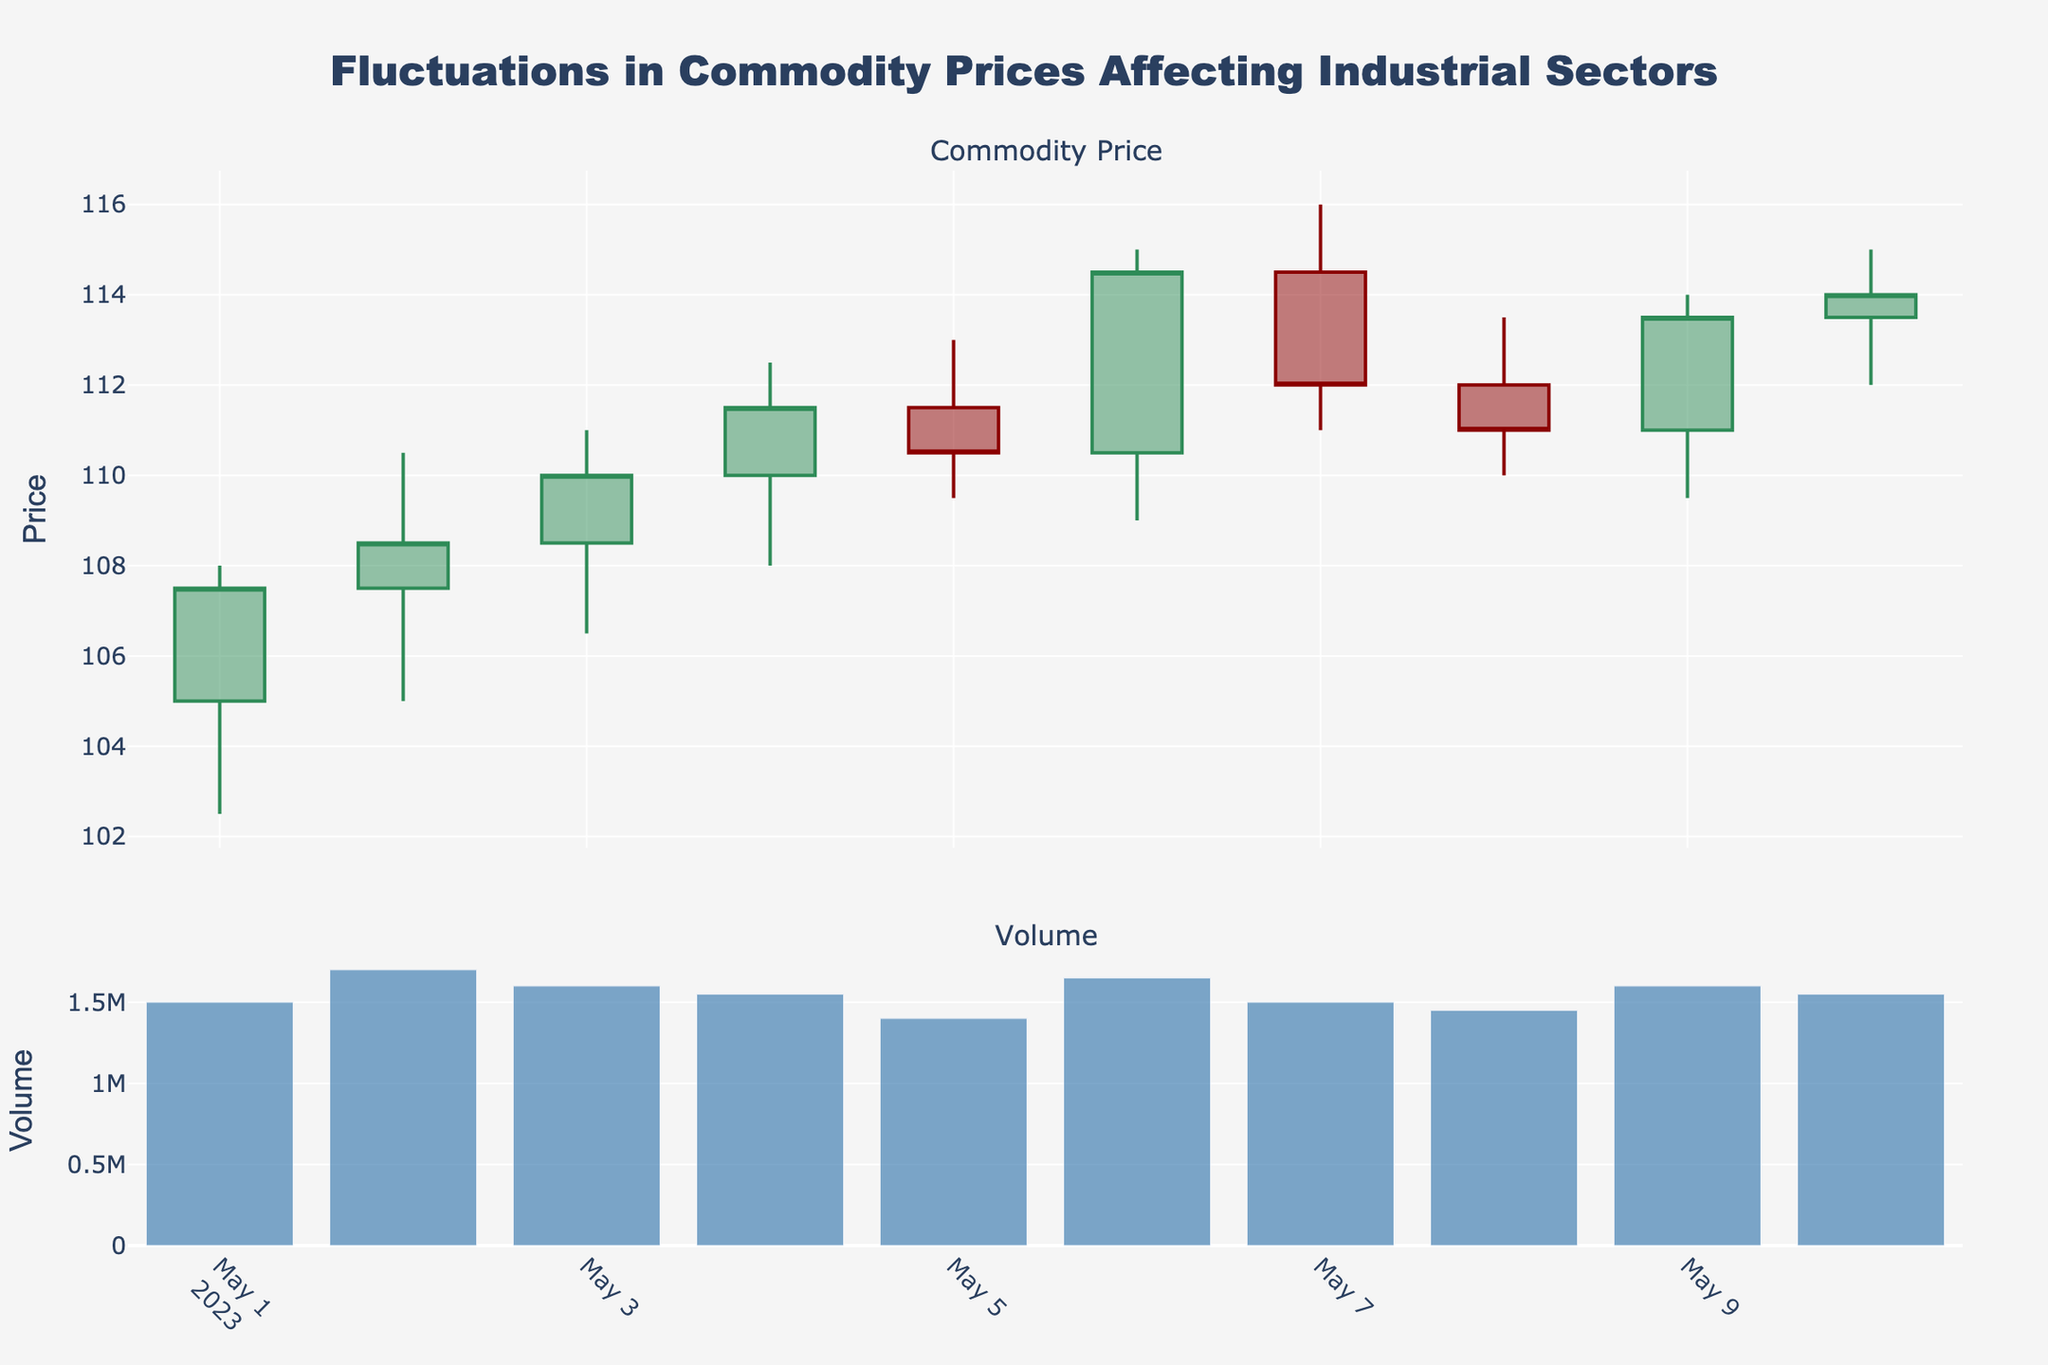What elements are represented along the x-axis? The x-axis represents the dates over which the stock price and volume are plotted. By examining the x-axis, we can see dates from May 1, 2023, to May 10, 2023.
Answer: The dates from May 1, 2023, to May 10, 2023 What colors are used to indicate increasing and decreasing prices in the candlestick plot? The increasing prices are indicated by green lines, and the decreasing prices are indicated by red lines. This color coding helps to quickly identify price trends.
Answer: Green and red What's the highest closing price during this period? To find the highest closing price, we compare the closing prices on the chart: 107.50, 108.50, 110.00, 111.50, 110.50, 114.50, 112.00, 111.00, 113.50, 114.00. The highest closing price is 114.50 on May 6, 2023.
Answer: 114.50 By how much did the volume increase from May 5 to May 6? On May 5, the volume was 1,400,000, and on May 6, it was 1,650,000. The increase in volume can be calculated as 1,650,000 - 1,400,000 = 250,000.
Answer: 250,000 Between which two consecutive days did the stock price experience the largest increase in closing price? Look at the closing prices: May 1 (107.50), May 2 (108.50), May 3 (110.00), May 4 (111.50), May 5 (110.50), May 6 (114.50), May 7 (112.00), May 8 (111.00), May 9 (113.50), and May 10 (114.00). The largest increase is from May 5 to May 6, where the price increased from 110.50 to 114.50, which is an increase of 4.00.
Answer: May 5 to May 6 Which day had the highest trading volume and what was the volume? By examining the bar chart for volume, we see May 2 had the highest volume of 1,700,000.
Answer: May 2, 1,700,000 What is noticeable about the price trend from May 1 to May 10? Observing the candlestick chart, the overall trend from May 1 to May 10 shows an upward movement with a few fluctuations. The price started at 107.50 on May 1 and ended at 114.00 on May 10.
Answer: Overall upward trend How does the volume on the last day compare to the volume on the first day? The volume on the last day (May 10) is 1,550,000, and on the first day (May 1), it is 1,500,000. The volume on May 10 is slightly higher by 50,000.
Answer: 50,000 higher What was the price change on May 3? On May 3, the opening price was 108.50 and the closing price was 110.00. The price change is the difference between these two values, which is 110.00 - 108.50 = 1.50.
Answer: 1.50 Which day had the narrowest range between the high and low prices? The ranges for each day are: 
May 1: 5.50 
May 2: 5.50 
May 3: 4.50 
May 4: 4.50 
May 5: 3.50 
May 6: 6.00 
May 7: 5.00 
May 8: 3.50 
May 9: 4.50 
May 10: 3.00 
The narrowest range of 3.00 occurred on May 10.
Answer: May 10 